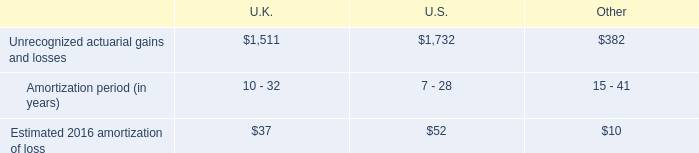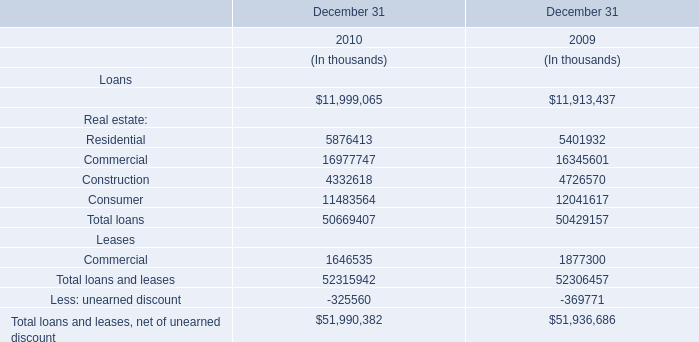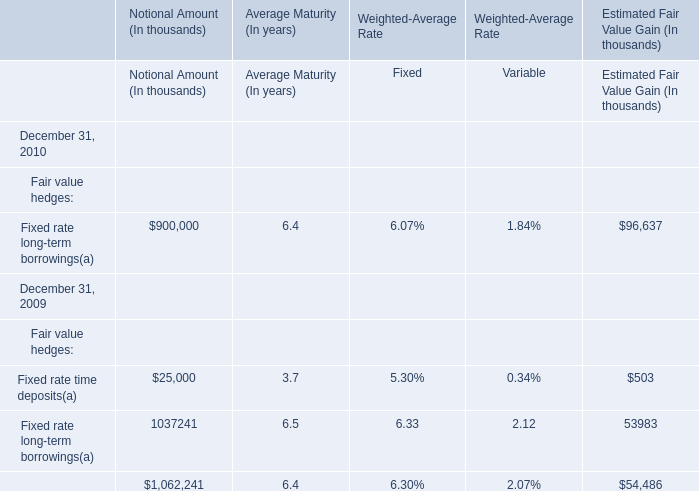What is the growing rate of the Notional Amount of the Fixed rate long-term borrowings between 2009 and 2010 as of December 31? 
Computations: ((900000 - 1037241) / 1037241)
Answer: -0.13231. 